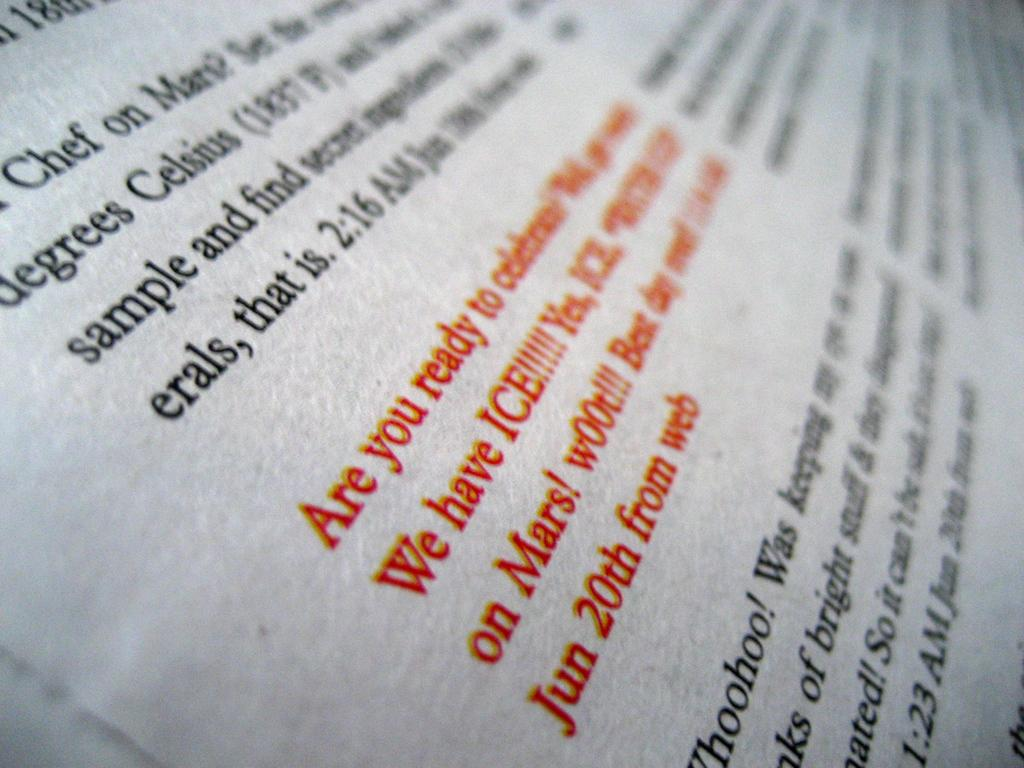What is present in the image that can be read? There is text in the image. What color is the text in the image? The text is in red color and black color. What type of silk fabric is being used to create the text in the image? There is no silk fabric present in the image; the text is in red and black colors. 